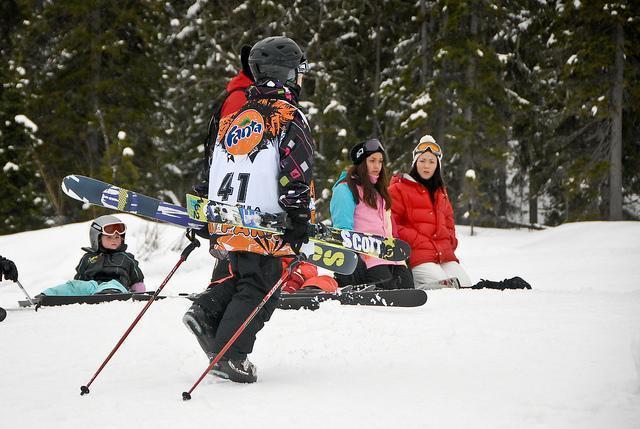What color are the poles dragged around by the young child with his skis?
Select the correct answer and articulate reasoning with the following format: 'Answer: answer
Rationale: rationale.'
Options: Black, orange, white, red. Answer: red.
Rationale: This is obvious by just looking at the poles. 